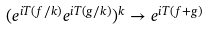<formula> <loc_0><loc_0><loc_500><loc_500>( e ^ { i T ( f / k ) } e ^ { i T ( g / k ) } ) ^ { k } \to e ^ { i T ( f + g ) }</formula> 